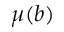<formula> <loc_0><loc_0><loc_500><loc_500>\mu ( b )</formula> 